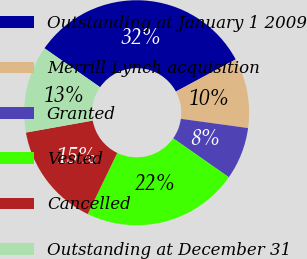Convert chart to OTSL. <chart><loc_0><loc_0><loc_500><loc_500><pie_chart><fcel>Outstanding at January 1 2009<fcel>Merrill Lynch acquisition<fcel>Granted<fcel>Vested<fcel>Cancelled<fcel>Outstanding at December 31<nl><fcel>32.42%<fcel>10.04%<fcel>7.54%<fcel>22.44%<fcel>15.02%<fcel>12.53%<nl></chart> 